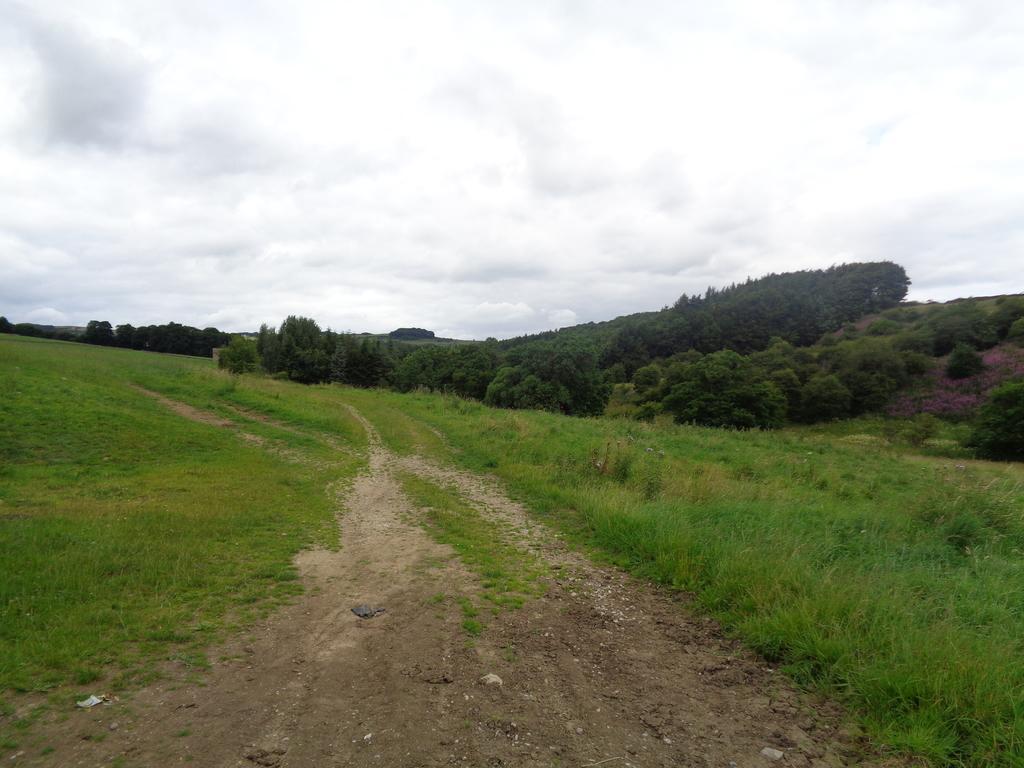Could you give a brief overview of what you see in this image? In this picture we can see the grass, trees, path and in the background we can see the sky with clouds. 